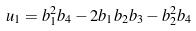Convert formula to latex. <formula><loc_0><loc_0><loc_500><loc_500>u _ { 1 } = b _ { 1 } ^ { 2 } b _ { 4 } - 2 b _ { 1 } b _ { 2 } b _ { 3 } - b _ { 2 } ^ { 2 } b _ { 4 }</formula> 